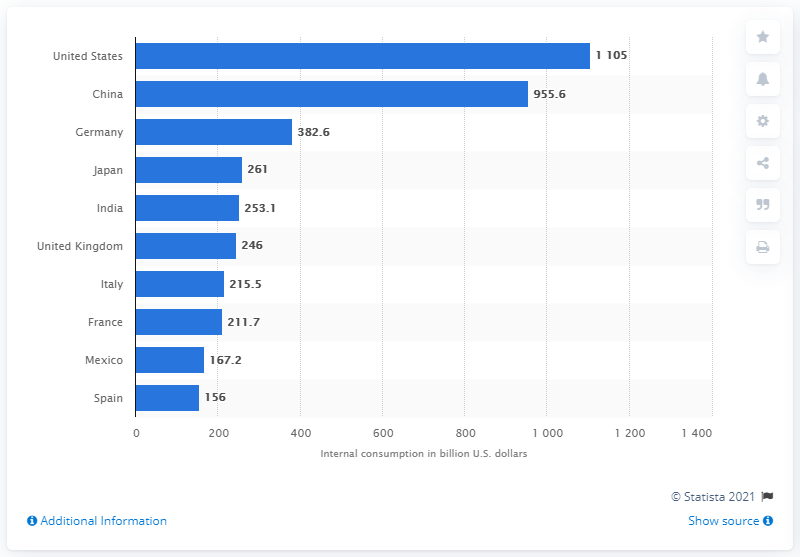Highlight a few significant elements in this photo. China came in second in the ranking. 